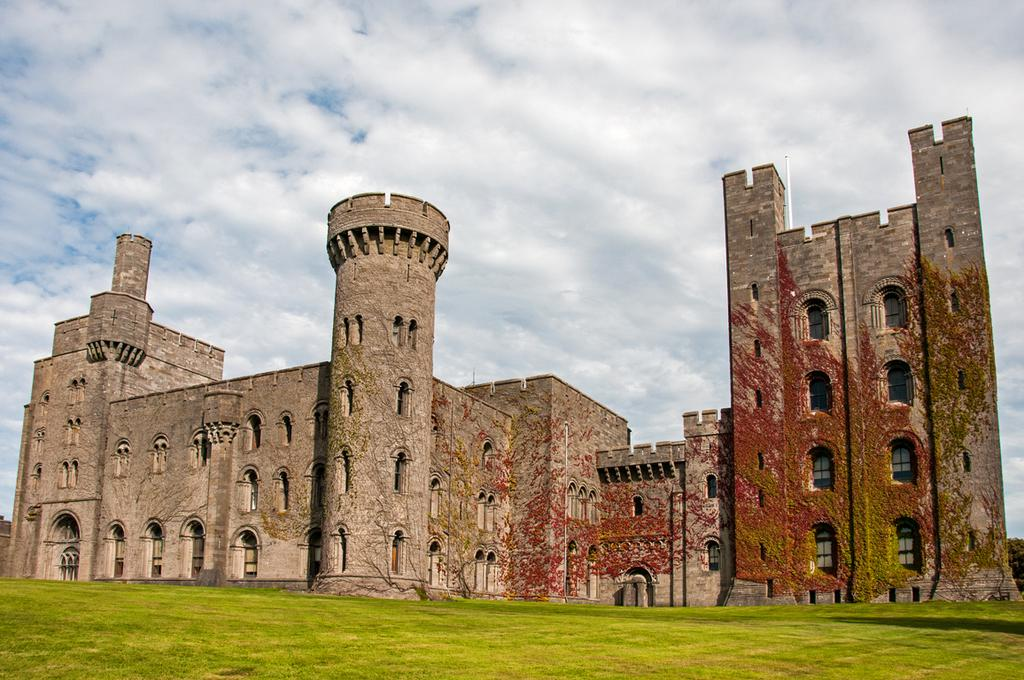What type of structure is in the picture? There is a fort in the picture. What is on the ground in the picture? There is grass on the ground in the picture. How would you describe the sky in the picture? The sky is blue and cloudy in the picture. Are there any bears eating yams in the picture? No, there are no bears or yams present in the image. 